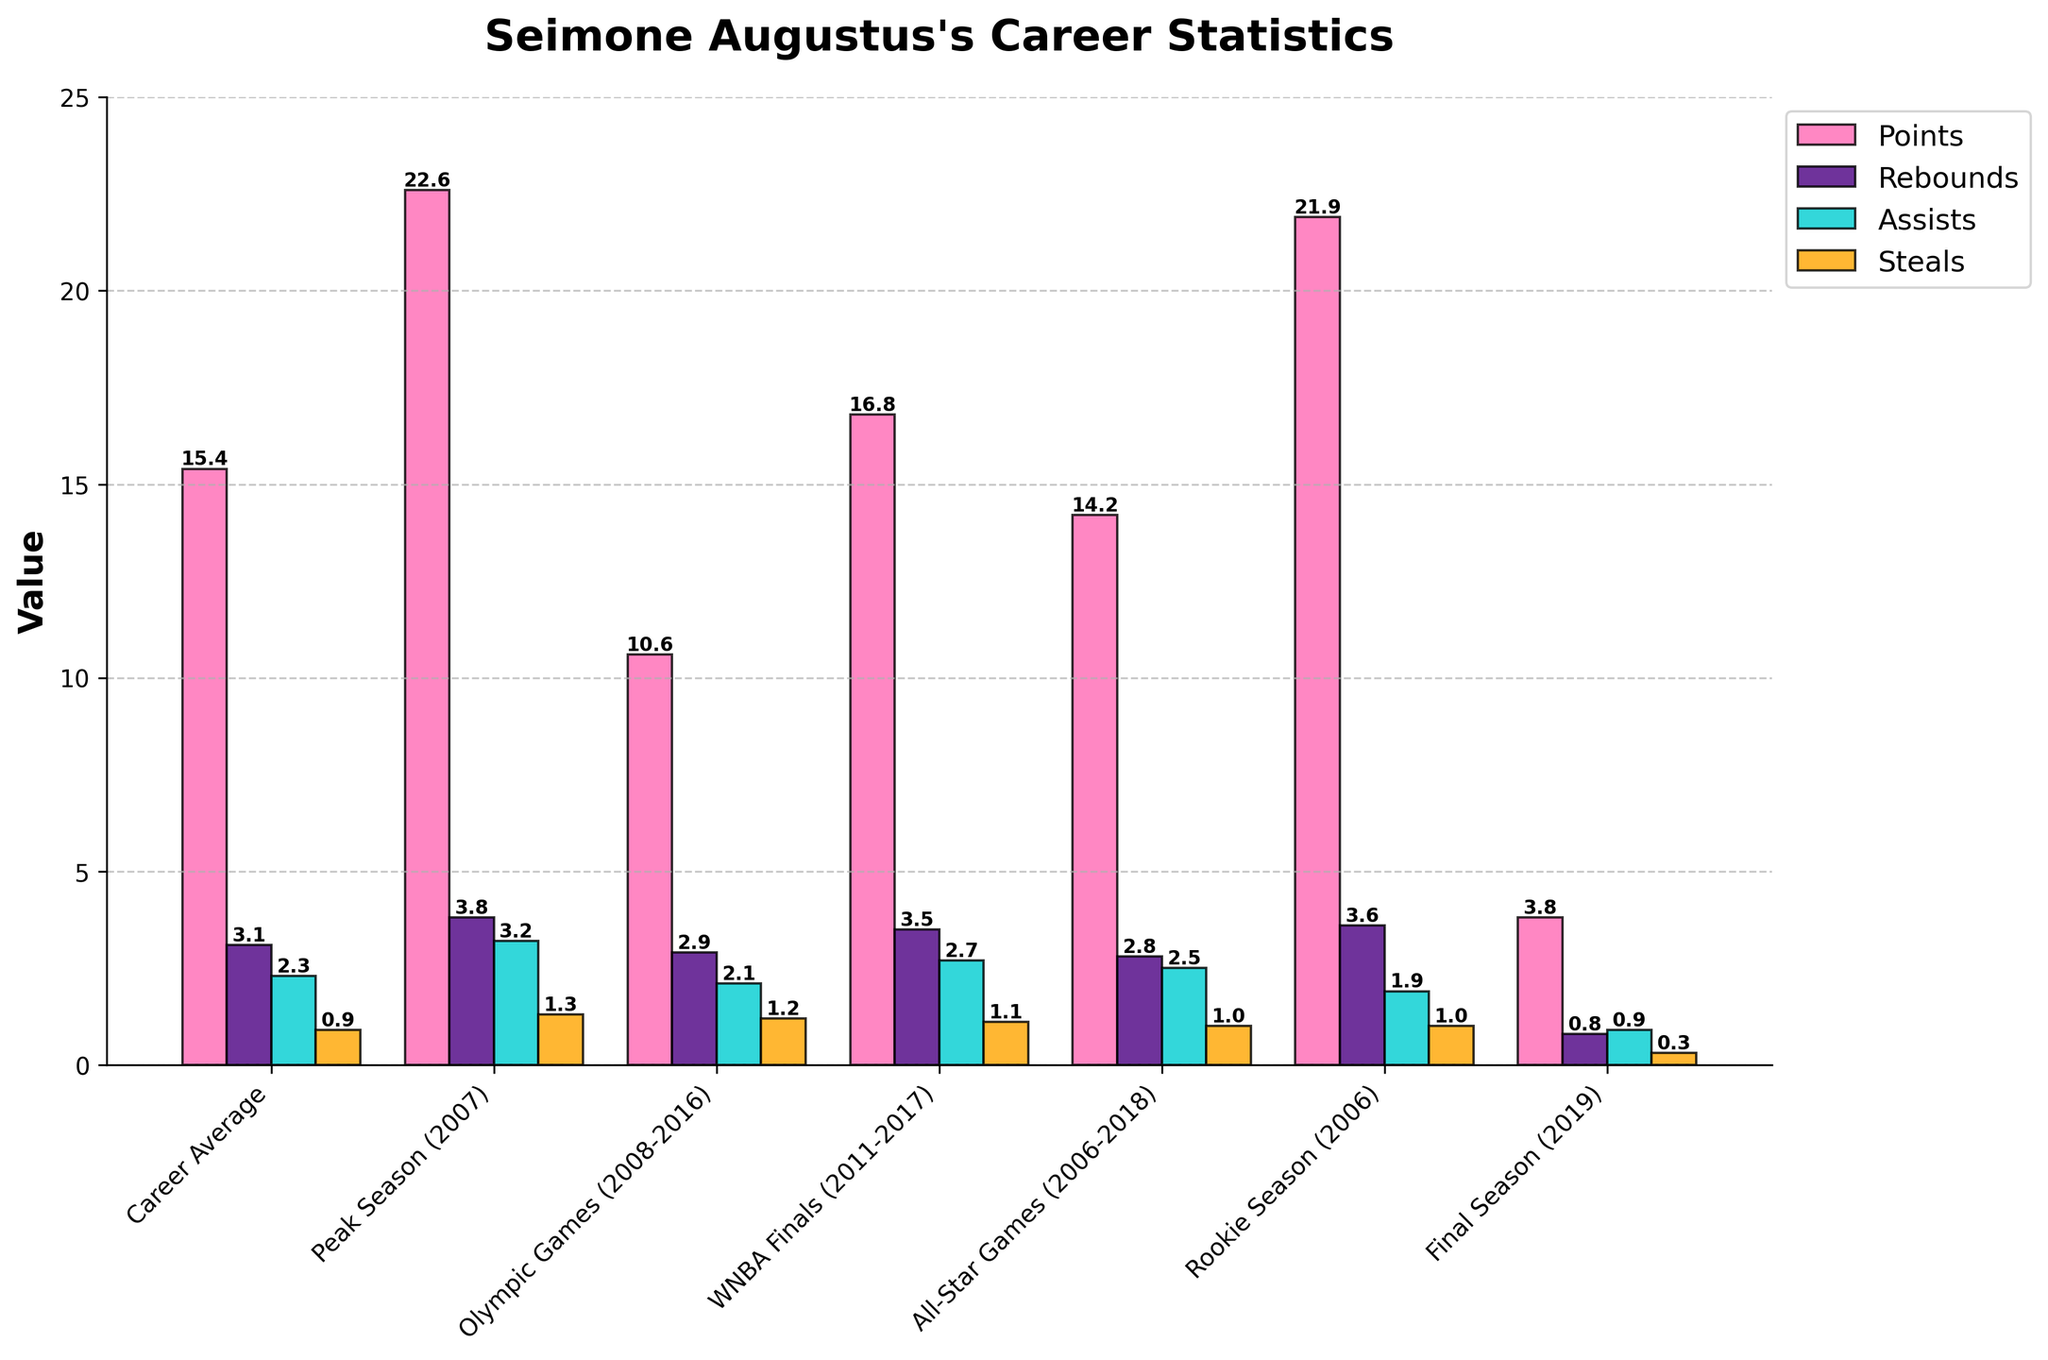What category did Seimone Augustus score the most points? By comparing the heights of the colored bars representing 'Points' in each category, the category with the tallest bar for points is "Peak Season (2007)" scoring 22.6 points.
Answer: Peak Season (2007) Which category shows the lowest assists? The category with the shortest bar for 'Assists' is "Final Season (2019)" with 0.9 assists.
Answer: Final Season (2019) What’s the difference in the number of points between Seimone Augustus's Rookie Season and Career Average? The points in her Rookie Season are 21.9 and her Career Average points are 15.4. The difference is 21.9 - 15.4 = 6.5.
Answer: 6.5 In which two categories did Seimone Augustus have equal amounts of steals, and what was that value? The bars representing 'Steals' for both "Rookie Season (2006)" and "All-Star Games (2006-2018)" reach the same height. The value is 1.0.
Answer: Rookie Season (2006), All-Star Games (2006-2018), 1.0 Which category had the highest rebounds, and what was the value? The category with the tallest bar for 'Rebounds' is "Peak Season (2007)" with a value of 3.8.
Answer: Peak Season (2007), 3.8 How do Seimone Augustus's assists in Olympic Games compare to her assists in All-Star Games? The bar for 'Assists' in "Olympic Games (2008-2016)" reaches 2.1, while in "All-Star Games (2006-2018)" it reaches 2.5. Since 2.1 is less than 2.5, her assists in Olympic Games were fewer compared to All-Star Games.
Answer: Fewer in Olympic Games What's the sum of points scored in Olympic Games and WNBA Finals? Points in "Olympic Games (2008-2016)" are 10.6 and in "WNBA Finals (2011-2017)" are 16.8. The sum is 10.6 + 16.8 = 27.4.
Answer: 27.4 In which category did Seimone Augustus perform best in terms of steals and why? The tallest bar for steals is in "Peak Season (2007)" with 1.3 steals. Performing best is determined by the highest value.
Answer: Peak Season (2007) What's the average number of rebounds across all shown categories? Adding all rebound values: 3.1 (Career Average) + 3.8 (Peak Season) + 2.9 (Olympic Games) + 3.5 (WNBA Finals) + 2.8 (All-Star Games) + 3.6 (Rookie Season) + 0.8 (Final Season) = 20.5. There are 7 categories, so the average is 20.5 / 7 = 2.93.
Answer: 2.93 How much more did Seimone Augustus assist in her Peak Season compared to her Final Season? Assists in Peak Season are 3.2 and in Final Season are 0.9. The difference is 3.2 - 0.9 = 2.3.
Answer: 2.3 